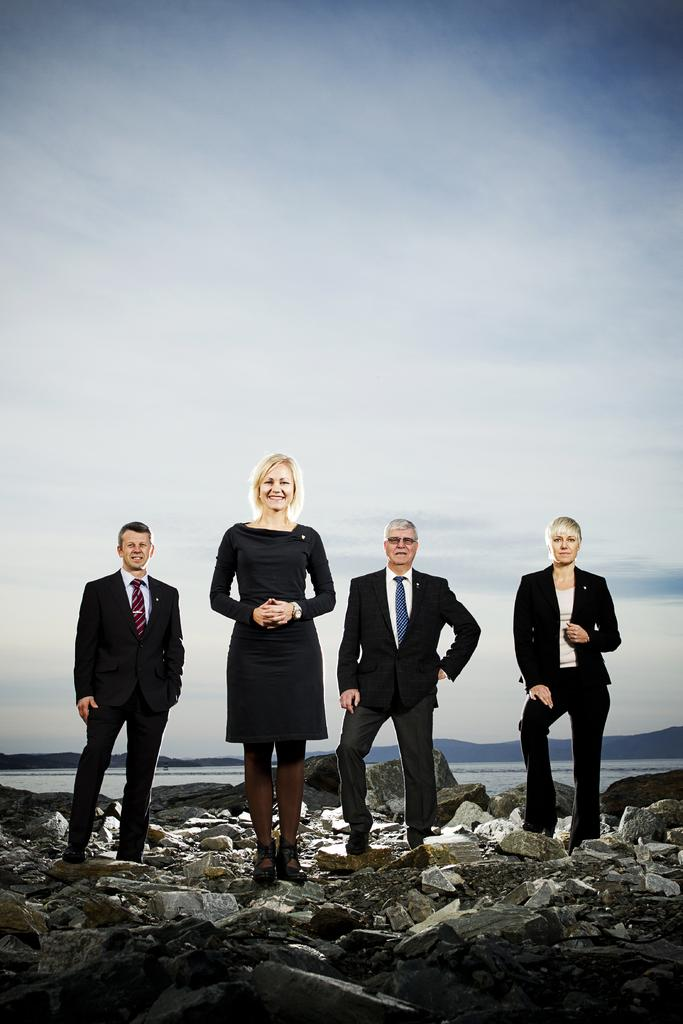How many people are in the image? There are four persons in the image. What are the persons standing on? The persons are standing on stones. What can be seen at the top of the image? The sky is visible at the top of the image. Can you describe the woman in the image? There is a woman in the image, and she is smiling. How many sheep are present on the stage in the image? There are no sheep or stage present in the image. What is the distribution of the sweets among the four persons in the image? There are no sweets mentioned in the image, so we cannot determine their distribution. 